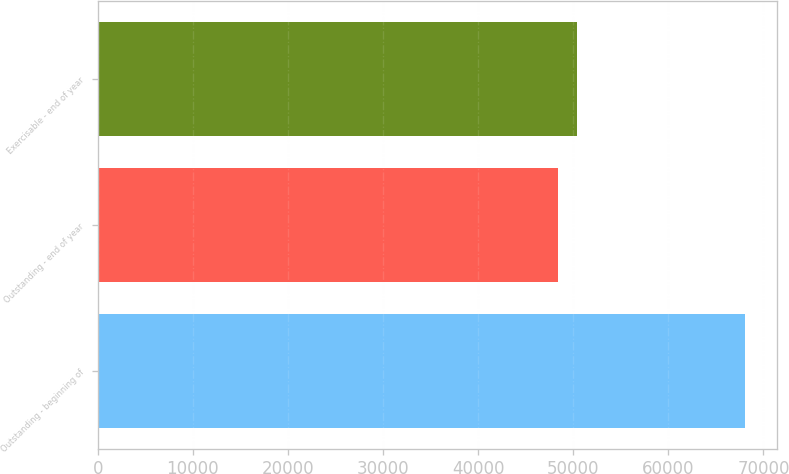Convert chart. <chart><loc_0><loc_0><loc_500><loc_500><bar_chart><fcel>Outstanding - beginning of<fcel>Outstanding - end of year<fcel>Exercisable - end of year<nl><fcel>68071<fcel>48446<fcel>50408.5<nl></chart> 